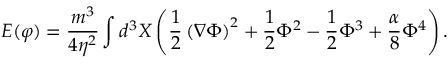Convert formula to latex. <formula><loc_0><loc_0><loc_500><loc_500>E ( \varphi ) = \frac { m ^ { 3 } } { 4 \eta ^ { 2 } } \int d ^ { 3 } X \left ( { \frac { 1 } { 2 } } \left ( \nabla \Phi \right ) ^ { 2 } + { \frac { 1 } { 2 } } \Phi ^ { 2 } - { \frac { 1 } { 2 } } \Phi ^ { 3 } + { \frac { \alpha } { 8 } } \Phi ^ { 4 } \right ) .</formula> 